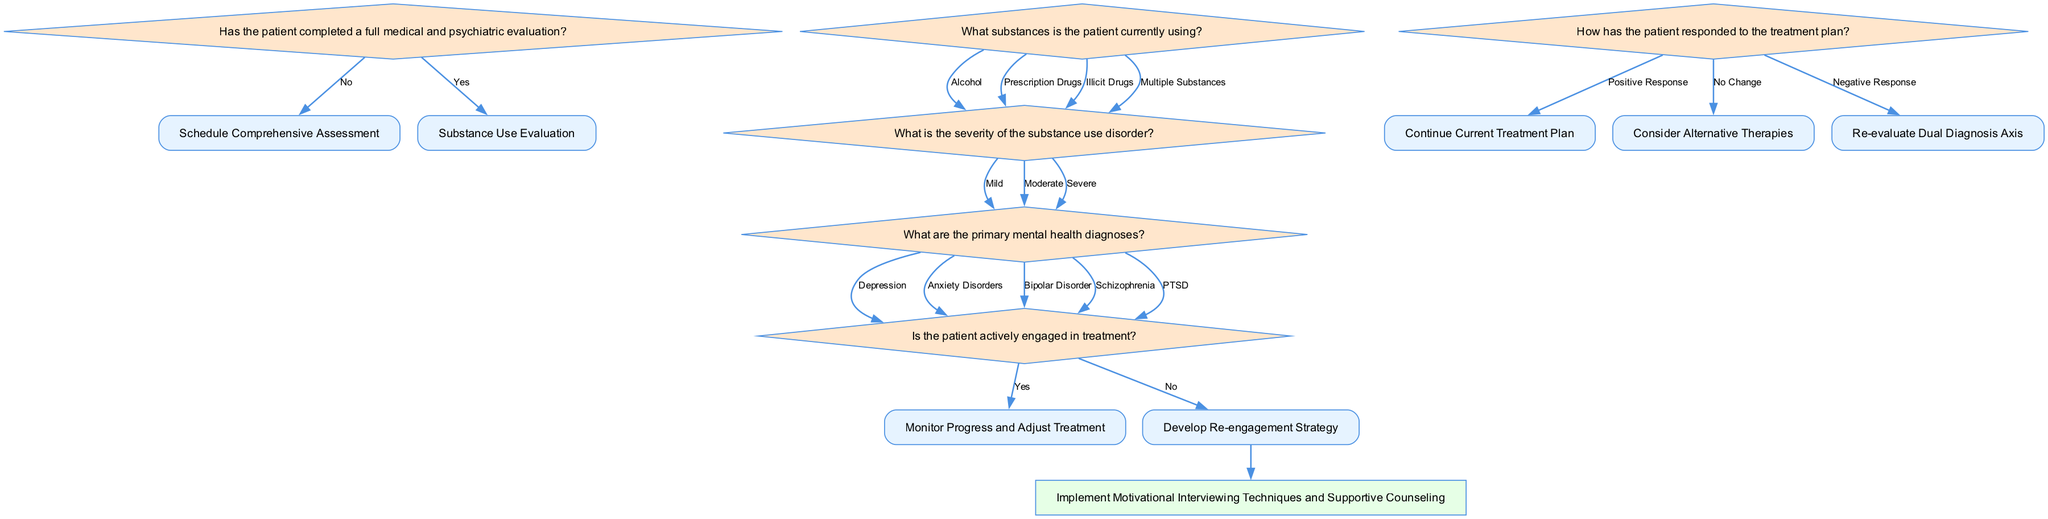What is the first question in the flowchart? The first question in the flowchart is located at the 'Initial Assessment' node. It asks if the patient has completed a full medical and psychiatric evaluation.
Answer: Has the patient completed a full medical and psychiatric evaluation? What step follows if the answer is 'Yes' to the first question? According to the flowchart, if the patient answers 'Yes' to the first question, the next step is to proceed to the 'Substance Use Evaluation'.
Answer: Proceed to Substance Use Evaluation How many primary mental health diagnoses are listed in the diagram? The diagram includes a step where the primary mental health diagnoses are listed. There are five specific diagnoses listed: Depression, Anxiety Disorders, Bipolar Disorder, Schizophrenia, and PTSD.
Answer: Five What action is taken if the patient is not actively engaged in treatment? The flowchart indicates that if the patient is not actively engaged in treatment, the next action is to develop a re-engagement strategy.
Answer: Develop Re-engagement Strategy If a patient responds positively to the treatment plan, what is the next step? The flowchart outlines that if a patient responds positively to the treatment plan, the next step is to continue the current treatment plan.
Answer: Continue Current Treatment Plan What are the substance use severity options shown in the flowchart? The flowchart specifies three options for the severity of the substance use disorder, namely Mild, Moderate, and Severe.
Answer: Mild, Moderate, Severe What node follows the 'Assess Treatment Engagement' decision node? After the 'Assess Treatment Engagement' decision node, two actions can be taken based on the response: either monitor progress and adjust treatment or develop a re-engagement strategy if the answer is 'No'.
Answer: Monitor Progress and Adjust Treatment or Develop Re-engagement Strategy Which node is related to 'Implement Motivational Interviewing Techniques'? The 'Implement Motivational Interviewing Techniques and Supportive Counseling' action is found at the 'Develop Re-engagement Strategy' node, indicating this strategy is directly related to improving patient engagement.
Answer: Develop Re-engagement Strategy 